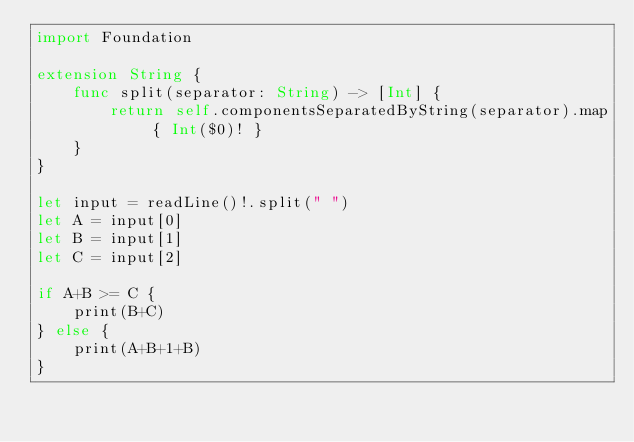<code> <loc_0><loc_0><loc_500><loc_500><_Swift_>import Foundation

extension String {
    func split(separator: String) -> [Int] {
        return self.componentsSeparatedByString(separator).map { Int($0)! }
    }
}

let input = readLine()!.split(" ")
let A = input[0]
let B = input[1]
let C = input[2]

if A+B >= C {
    print(B+C)
} else {
    print(A+B+1+B)
}</code> 